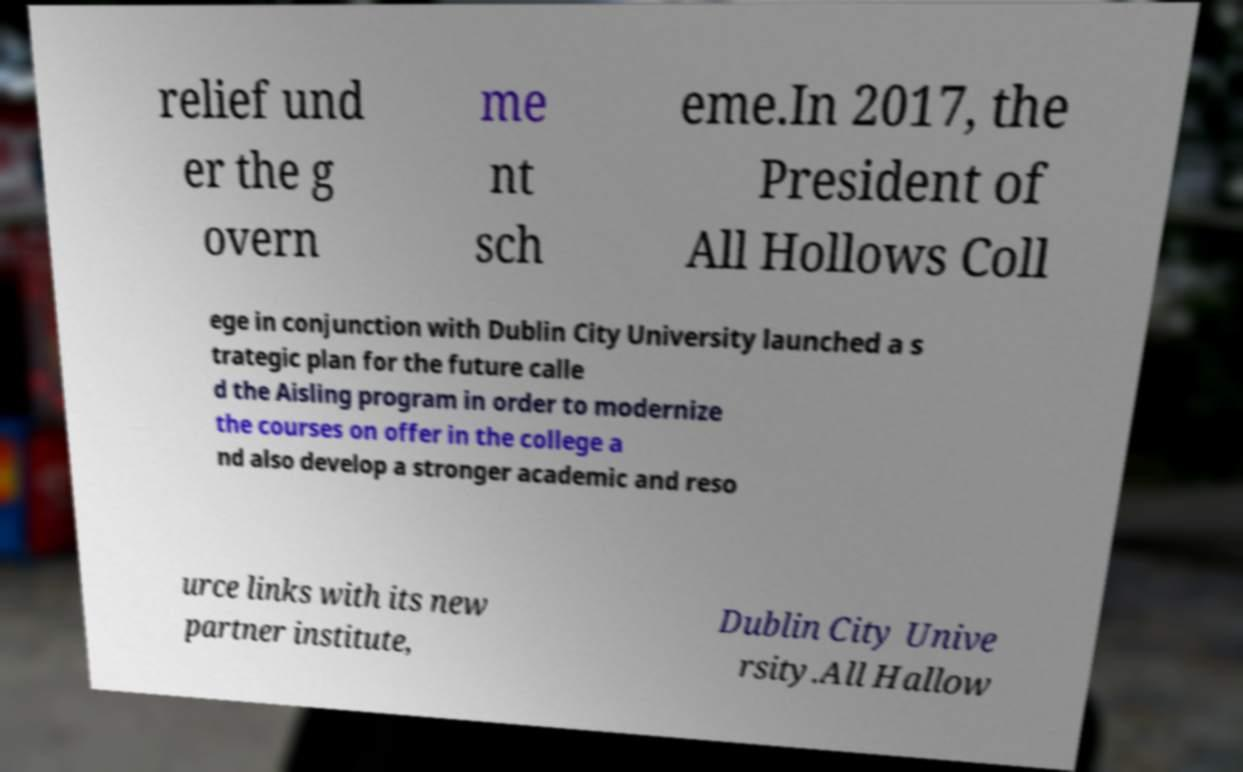For documentation purposes, I need the text within this image transcribed. Could you provide that? relief und er the g overn me nt sch eme.In 2017, the President of All Hollows Coll ege in conjunction with Dublin City University launched a s trategic plan for the future calle d the Aisling program in order to modernize the courses on offer in the college a nd also develop a stronger academic and reso urce links with its new partner institute, Dublin City Unive rsity.All Hallow 